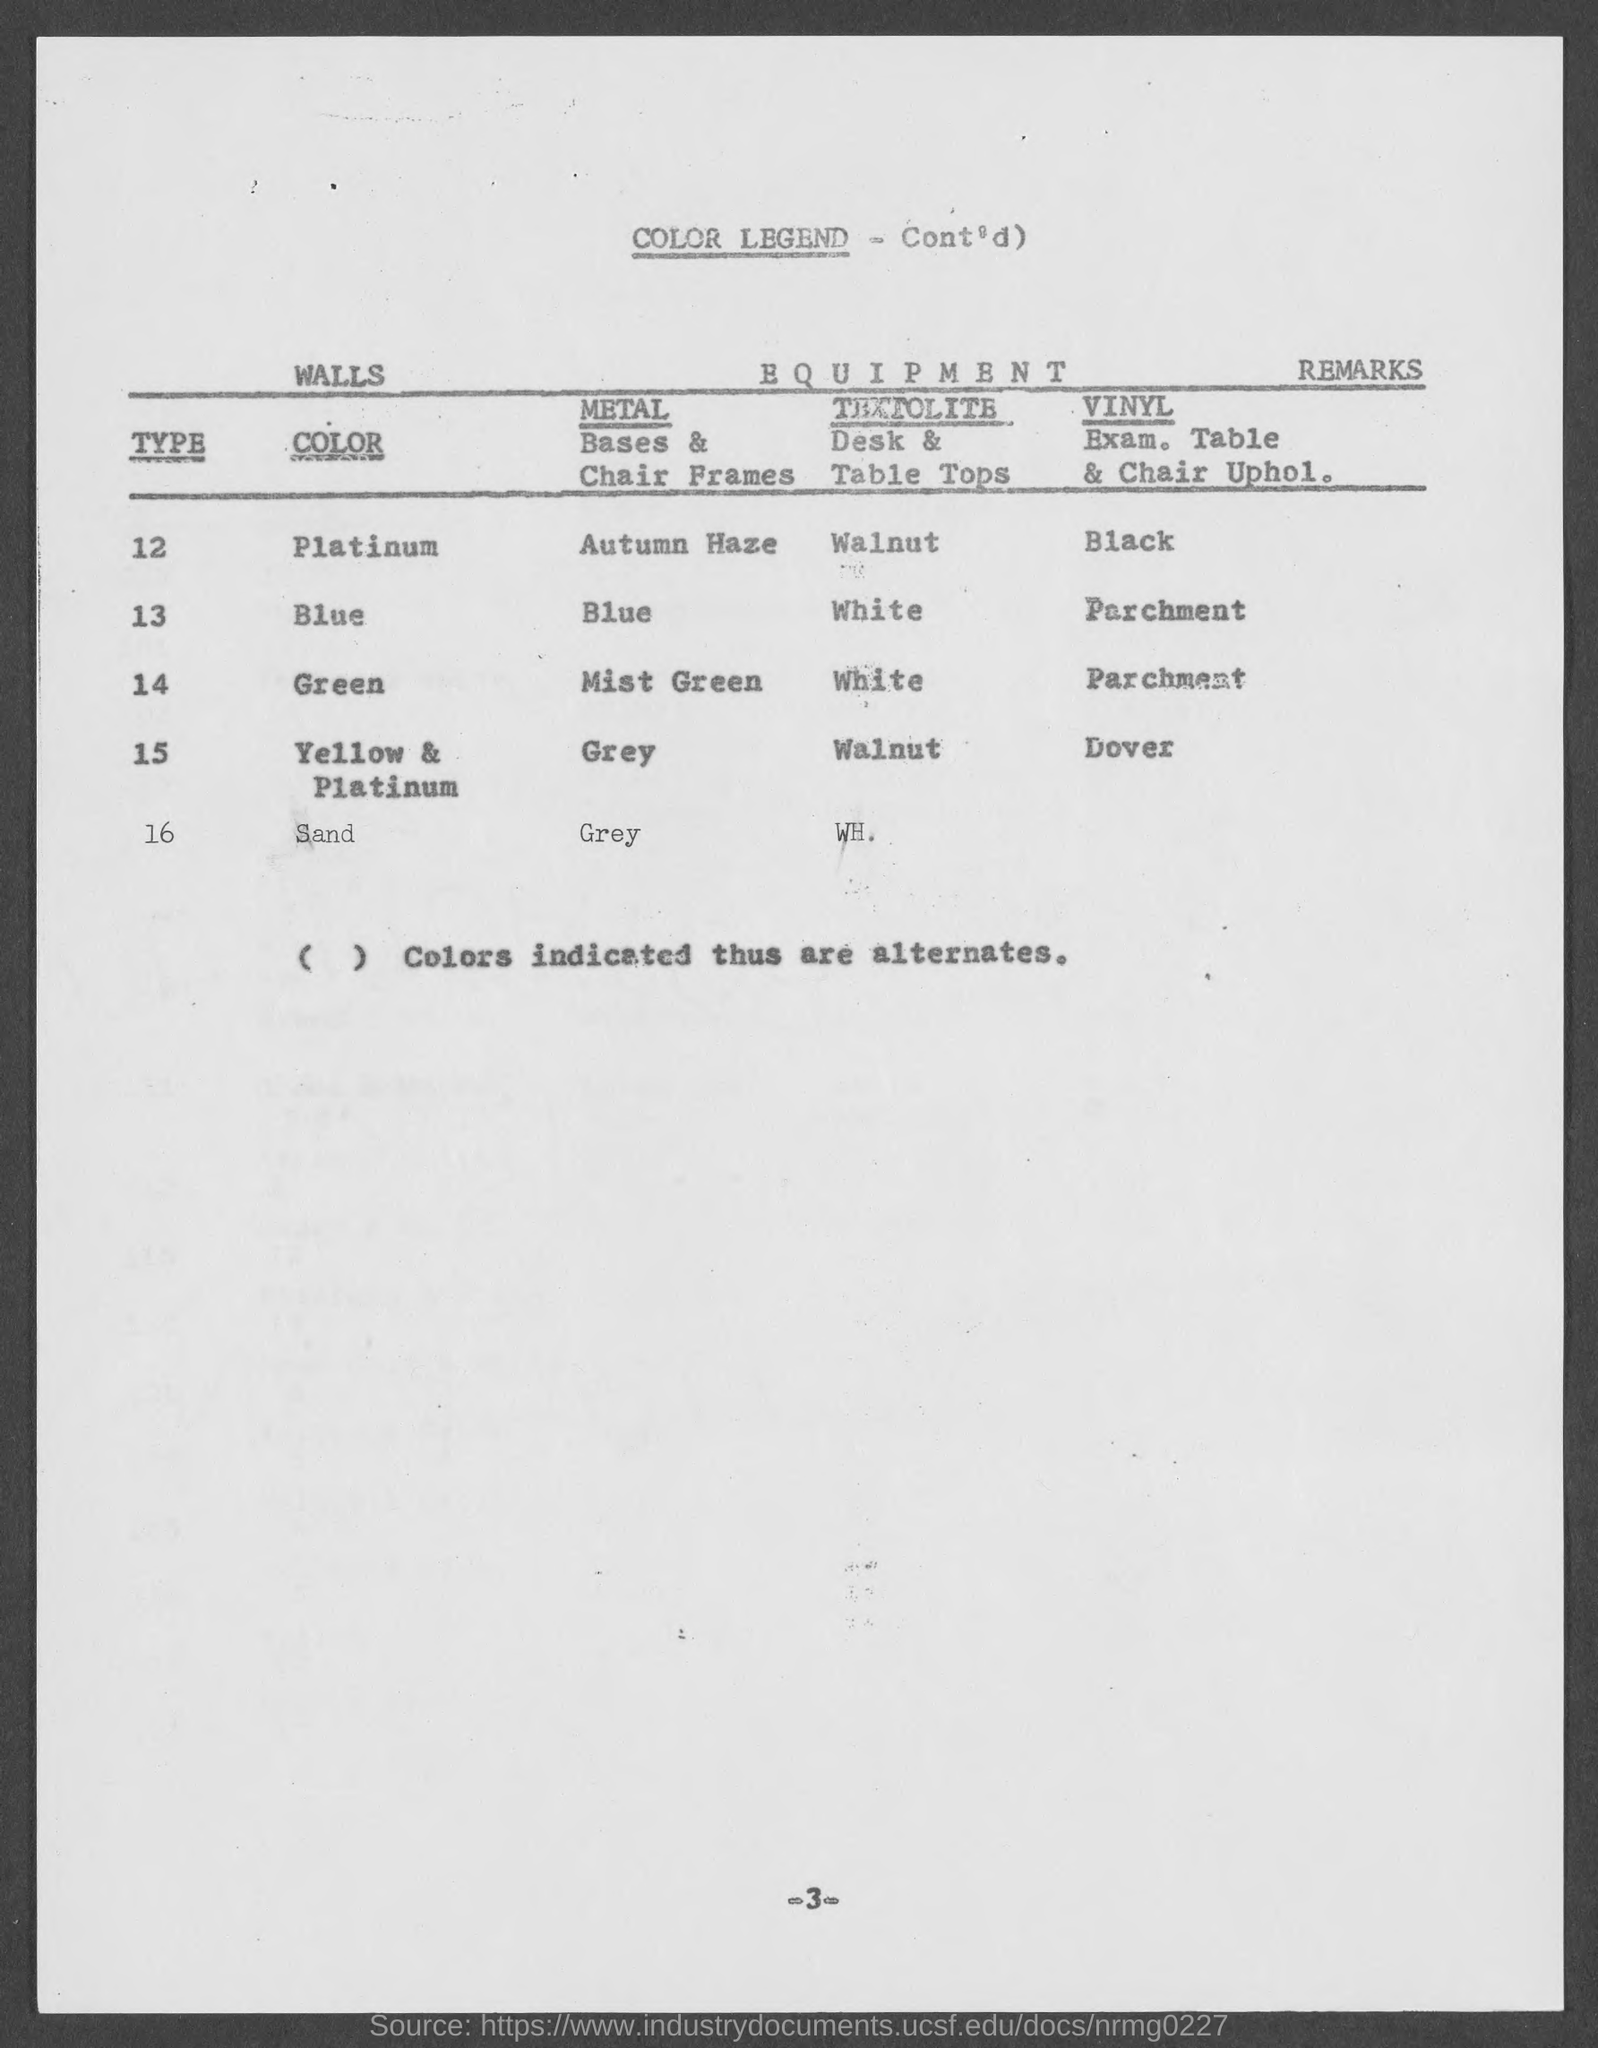Which color "Type 12" indicates?
Your answer should be very brief. PLATINUM. Which color "Type 14" indicates?
Offer a very short reply. Green. 